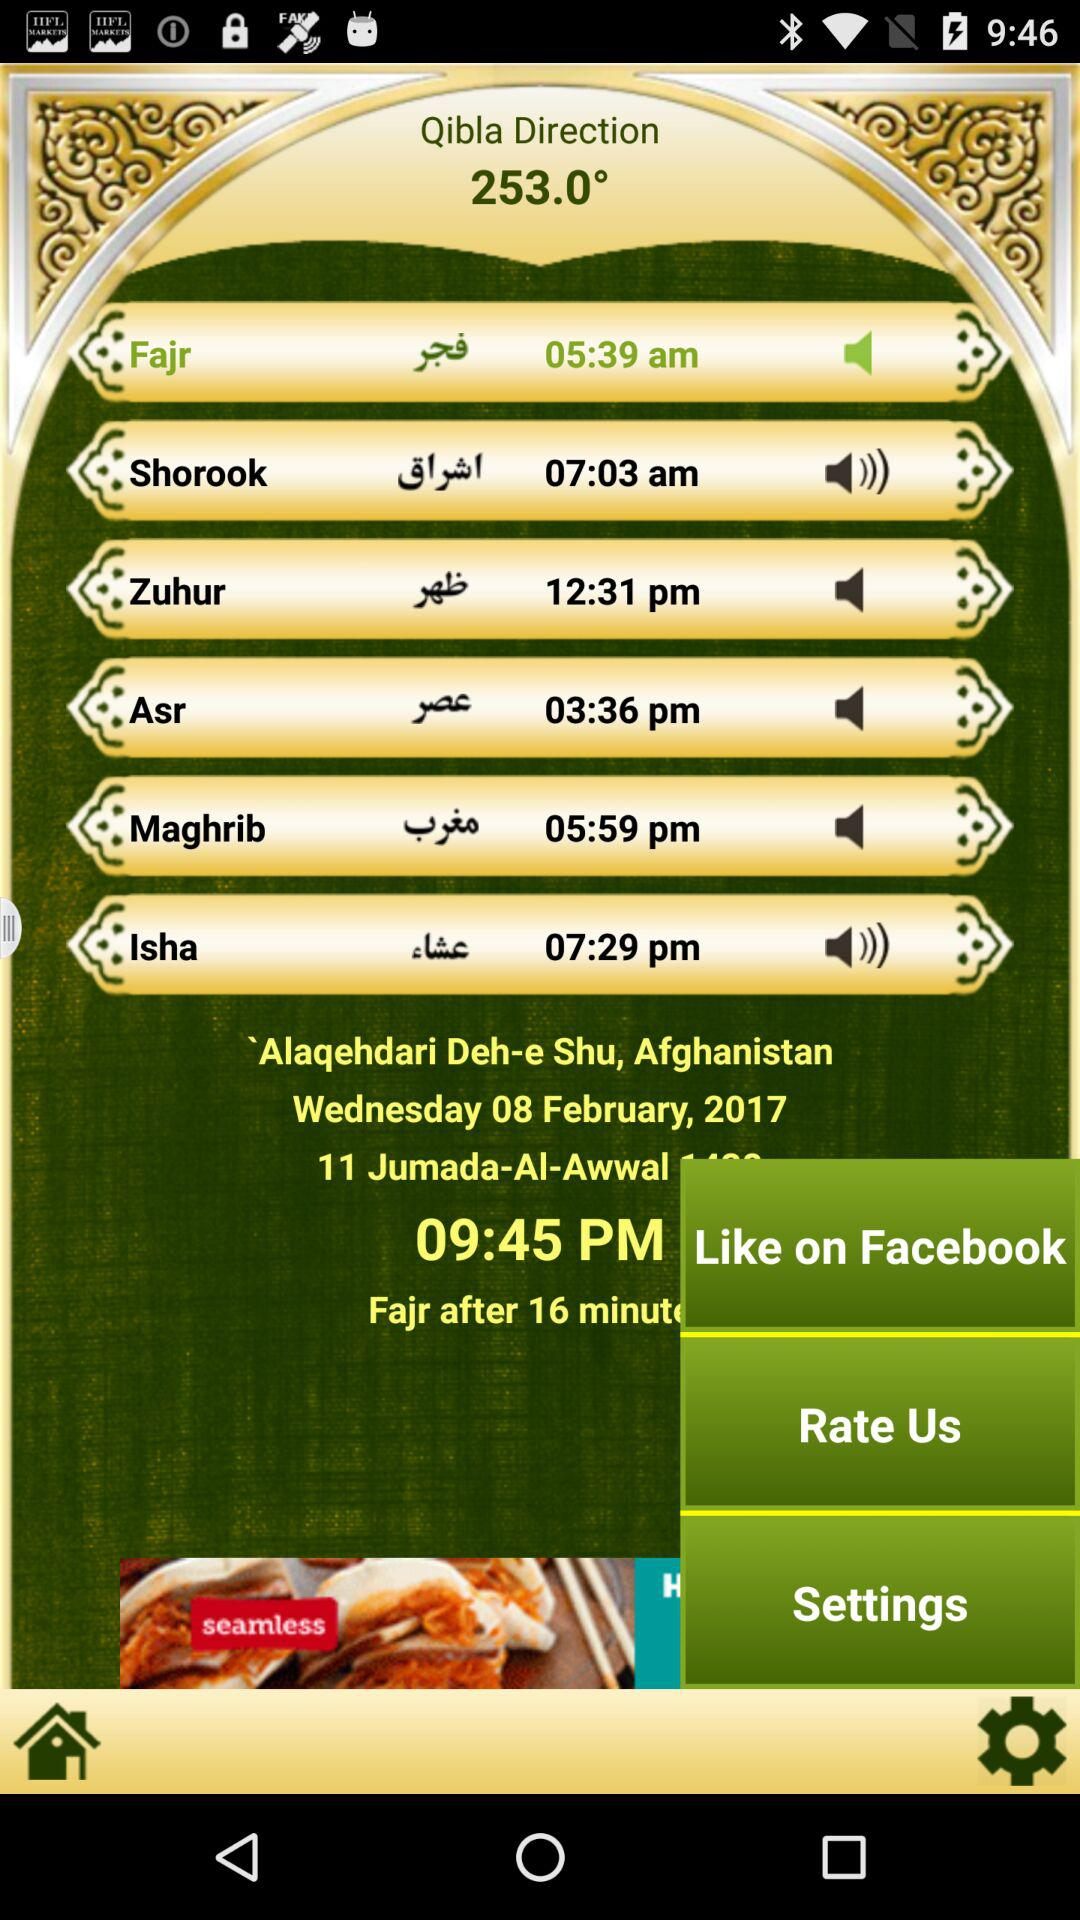What is the time of the prayer Isha? The time of the prayer is 07:29 pm. 